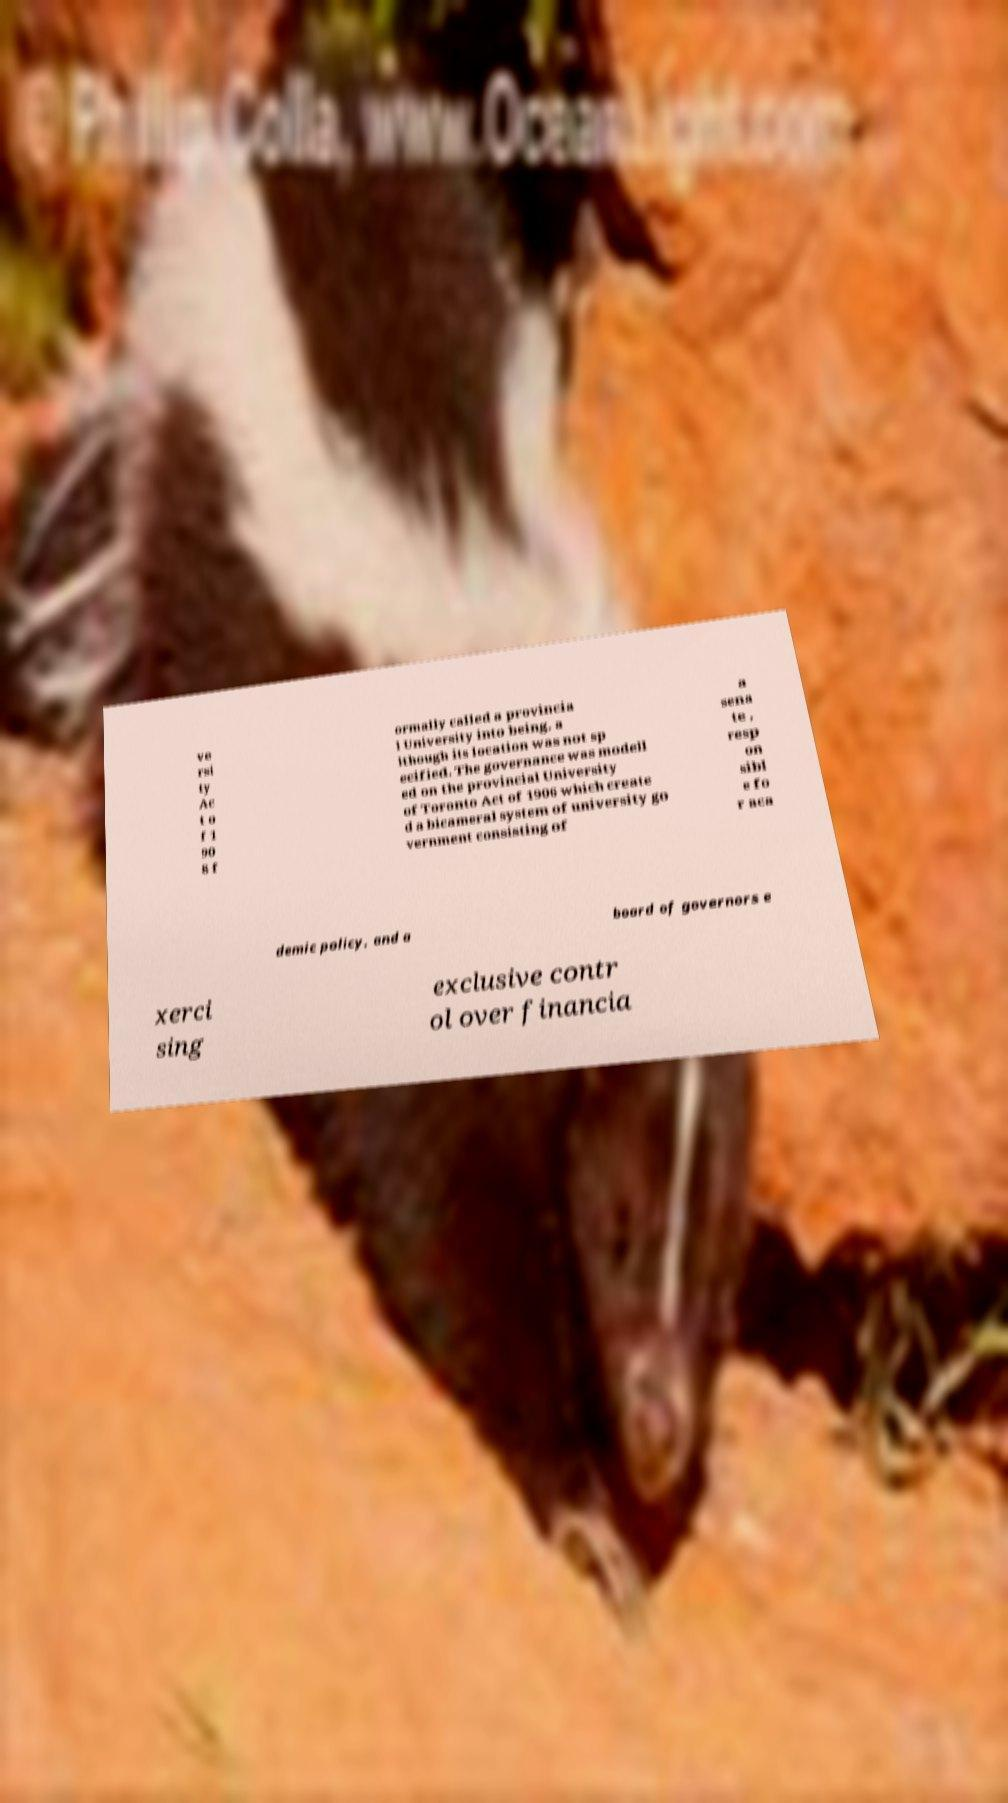Please identify and transcribe the text found in this image. ve rsi ty Ac t o f 1 90 8 f ormally called a provincia l University into being, a lthough its location was not sp ecified. The governance was modell ed on the provincial University of Toronto Act of 1906 which create d a bicameral system of university go vernment consisting of a sena te , resp on sibl e fo r aca demic policy, and a board of governors e xerci sing exclusive contr ol over financia 